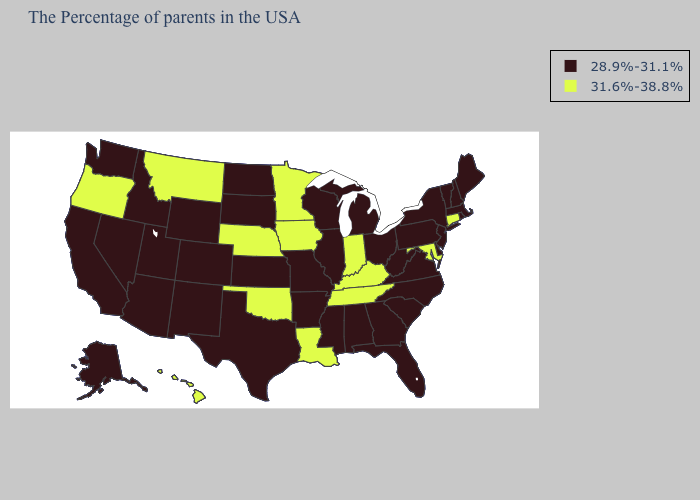Name the states that have a value in the range 31.6%-38.8%?
Write a very short answer. Connecticut, Maryland, Kentucky, Indiana, Tennessee, Louisiana, Minnesota, Iowa, Nebraska, Oklahoma, Montana, Oregon, Hawaii. What is the value of Delaware?
Quick response, please. 28.9%-31.1%. Which states have the highest value in the USA?
Concise answer only. Connecticut, Maryland, Kentucky, Indiana, Tennessee, Louisiana, Minnesota, Iowa, Nebraska, Oklahoma, Montana, Oregon, Hawaii. Among the states that border Kansas , does Nebraska have the lowest value?
Give a very brief answer. No. Name the states that have a value in the range 31.6%-38.8%?
Be succinct. Connecticut, Maryland, Kentucky, Indiana, Tennessee, Louisiana, Minnesota, Iowa, Nebraska, Oklahoma, Montana, Oregon, Hawaii. What is the highest value in states that border Massachusetts?
Answer briefly. 31.6%-38.8%. Does Connecticut have a higher value than Alabama?
Short answer required. Yes. Which states hav the highest value in the West?
Write a very short answer. Montana, Oregon, Hawaii. What is the lowest value in the USA?
Be succinct. 28.9%-31.1%. Does Montana have the highest value in the USA?
Be succinct. Yes. Does Vermont have the highest value in the USA?
Short answer required. No. Which states have the lowest value in the West?
Concise answer only. Wyoming, Colorado, New Mexico, Utah, Arizona, Idaho, Nevada, California, Washington, Alaska. What is the highest value in states that border Florida?
Quick response, please. 28.9%-31.1%. 